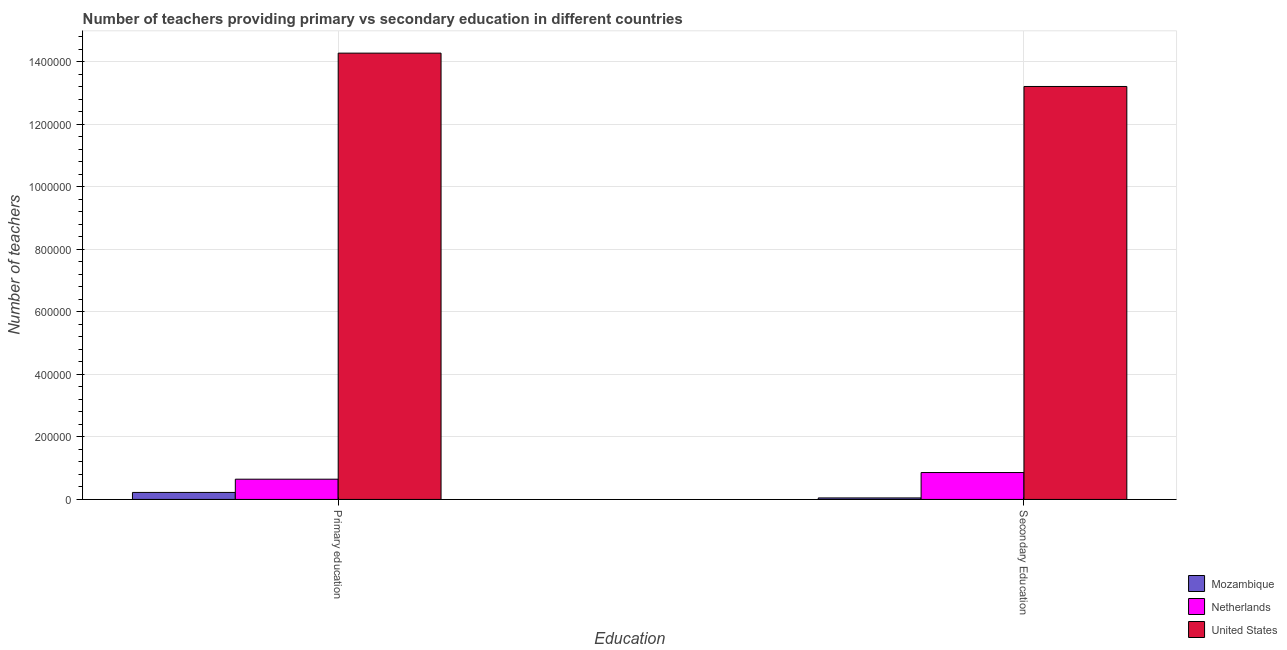How many groups of bars are there?
Your answer should be very brief. 2. Are the number of bars per tick equal to the number of legend labels?
Your response must be concise. Yes. Are the number of bars on each tick of the X-axis equal?
Give a very brief answer. Yes. How many bars are there on the 2nd tick from the left?
Make the answer very short. 3. What is the label of the 2nd group of bars from the left?
Offer a very short reply. Secondary Education. What is the number of secondary teachers in United States?
Your answer should be very brief. 1.32e+06. Across all countries, what is the maximum number of primary teachers?
Provide a short and direct response. 1.43e+06. Across all countries, what is the minimum number of primary teachers?
Provide a short and direct response. 2.24e+04. In which country was the number of secondary teachers minimum?
Make the answer very short. Mozambique. What is the total number of primary teachers in the graph?
Make the answer very short. 1.51e+06. What is the difference between the number of primary teachers in Mozambique and that in Netherlands?
Offer a very short reply. -4.23e+04. What is the difference between the number of primary teachers in United States and the number of secondary teachers in Netherlands?
Offer a very short reply. 1.34e+06. What is the average number of secondary teachers per country?
Your response must be concise. 4.71e+05. What is the difference between the number of secondary teachers and number of primary teachers in United States?
Give a very brief answer. -1.07e+05. What is the ratio of the number of primary teachers in Mozambique to that in United States?
Make the answer very short. 0.02. Is the number of primary teachers in United States less than that in Netherlands?
Provide a short and direct response. No. What does the 3rd bar from the left in Primary education represents?
Provide a short and direct response. United States. What does the 2nd bar from the right in Secondary Education represents?
Give a very brief answer. Netherlands. Are all the bars in the graph horizontal?
Ensure brevity in your answer.  No. Does the graph contain grids?
Make the answer very short. Yes. How many legend labels are there?
Provide a succinct answer. 3. How are the legend labels stacked?
Offer a terse response. Vertical. What is the title of the graph?
Keep it short and to the point. Number of teachers providing primary vs secondary education in different countries. What is the label or title of the X-axis?
Give a very brief answer. Education. What is the label or title of the Y-axis?
Provide a succinct answer. Number of teachers. What is the Number of teachers in Mozambique in Primary education?
Give a very brief answer. 2.24e+04. What is the Number of teachers in Netherlands in Primary education?
Your answer should be very brief. 6.47e+04. What is the Number of teachers of United States in Primary education?
Give a very brief answer. 1.43e+06. What is the Number of teachers of Mozambique in Secondary Education?
Ensure brevity in your answer.  4809. What is the Number of teachers of Netherlands in Secondary Education?
Make the answer very short. 8.60e+04. What is the Number of teachers of United States in Secondary Education?
Keep it short and to the point. 1.32e+06. Across all Education, what is the maximum Number of teachers in Mozambique?
Make the answer very short. 2.24e+04. Across all Education, what is the maximum Number of teachers in Netherlands?
Provide a short and direct response. 8.60e+04. Across all Education, what is the maximum Number of teachers of United States?
Make the answer very short. 1.43e+06. Across all Education, what is the minimum Number of teachers in Mozambique?
Make the answer very short. 4809. Across all Education, what is the minimum Number of teachers in Netherlands?
Your response must be concise. 6.47e+04. Across all Education, what is the minimum Number of teachers in United States?
Your answer should be compact. 1.32e+06. What is the total Number of teachers of Mozambique in the graph?
Offer a very short reply. 2.72e+04. What is the total Number of teachers in Netherlands in the graph?
Your response must be concise. 1.51e+05. What is the total Number of teachers in United States in the graph?
Provide a succinct answer. 2.75e+06. What is the difference between the Number of teachers of Mozambique in Primary education and that in Secondary Education?
Your response must be concise. 1.76e+04. What is the difference between the Number of teachers in Netherlands in Primary education and that in Secondary Education?
Offer a terse response. -2.13e+04. What is the difference between the Number of teachers in United States in Primary education and that in Secondary Education?
Your answer should be compact. 1.07e+05. What is the difference between the Number of teachers in Mozambique in Primary education and the Number of teachers in Netherlands in Secondary Education?
Offer a terse response. -6.36e+04. What is the difference between the Number of teachers of Mozambique in Primary education and the Number of teachers of United States in Secondary Education?
Provide a short and direct response. -1.30e+06. What is the difference between the Number of teachers in Netherlands in Primary education and the Number of teachers in United States in Secondary Education?
Your answer should be compact. -1.26e+06. What is the average Number of teachers of Mozambique per Education?
Keep it short and to the point. 1.36e+04. What is the average Number of teachers of Netherlands per Education?
Provide a succinct answer. 7.54e+04. What is the average Number of teachers in United States per Education?
Make the answer very short. 1.37e+06. What is the difference between the Number of teachers in Mozambique and Number of teachers in Netherlands in Primary education?
Offer a very short reply. -4.23e+04. What is the difference between the Number of teachers of Mozambique and Number of teachers of United States in Primary education?
Offer a terse response. -1.40e+06. What is the difference between the Number of teachers of Netherlands and Number of teachers of United States in Primary education?
Offer a very short reply. -1.36e+06. What is the difference between the Number of teachers in Mozambique and Number of teachers in Netherlands in Secondary Education?
Give a very brief answer. -8.12e+04. What is the difference between the Number of teachers of Mozambique and Number of teachers of United States in Secondary Education?
Ensure brevity in your answer.  -1.32e+06. What is the difference between the Number of teachers of Netherlands and Number of teachers of United States in Secondary Education?
Make the answer very short. -1.23e+06. What is the ratio of the Number of teachers in Mozambique in Primary education to that in Secondary Education?
Keep it short and to the point. 4.66. What is the ratio of the Number of teachers of Netherlands in Primary education to that in Secondary Education?
Provide a short and direct response. 0.75. What is the ratio of the Number of teachers in United States in Primary education to that in Secondary Education?
Keep it short and to the point. 1.08. What is the difference between the highest and the second highest Number of teachers in Mozambique?
Provide a short and direct response. 1.76e+04. What is the difference between the highest and the second highest Number of teachers in Netherlands?
Your answer should be very brief. 2.13e+04. What is the difference between the highest and the second highest Number of teachers in United States?
Keep it short and to the point. 1.07e+05. What is the difference between the highest and the lowest Number of teachers in Mozambique?
Provide a short and direct response. 1.76e+04. What is the difference between the highest and the lowest Number of teachers in Netherlands?
Provide a succinct answer. 2.13e+04. What is the difference between the highest and the lowest Number of teachers in United States?
Your answer should be compact. 1.07e+05. 